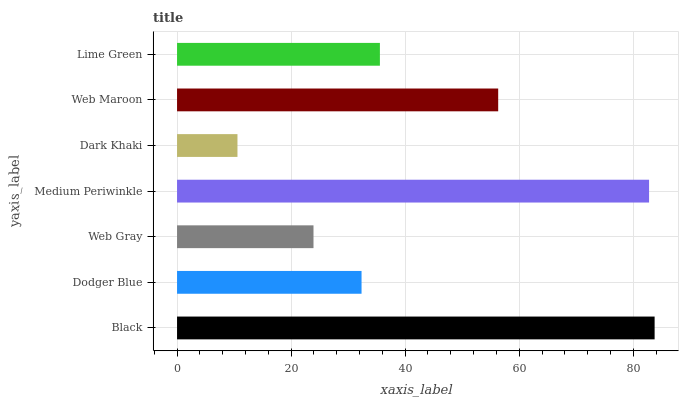Is Dark Khaki the minimum?
Answer yes or no. Yes. Is Black the maximum?
Answer yes or no. Yes. Is Dodger Blue the minimum?
Answer yes or no. No. Is Dodger Blue the maximum?
Answer yes or no. No. Is Black greater than Dodger Blue?
Answer yes or no. Yes. Is Dodger Blue less than Black?
Answer yes or no. Yes. Is Dodger Blue greater than Black?
Answer yes or no. No. Is Black less than Dodger Blue?
Answer yes or no. No. Is Lime Green the high median?
Answer yes or no. Yes. Is Lime Green the low median?
Answer yes or no. Yes. Is Web Gray the high median?
Answer yes or no. No. Is Black the low median?
Answer yes or no. No. 